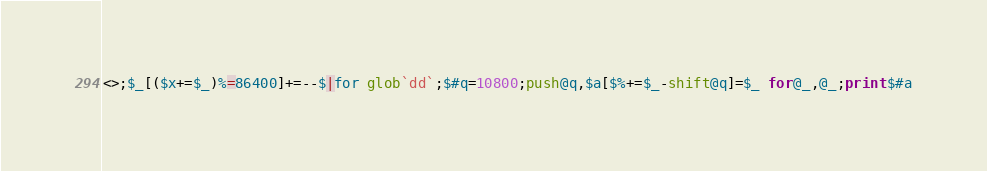Convert code to text. <code><loc_0><loc_0><loc_500><loc_500><_Perl_><>;$_[($x+=$_)%=86400]+=--$|for glob`dd`;$#q=10800;push@q,$a[$%+=$_-shift@q]=$_ for@_,@_;print$#a</code> 